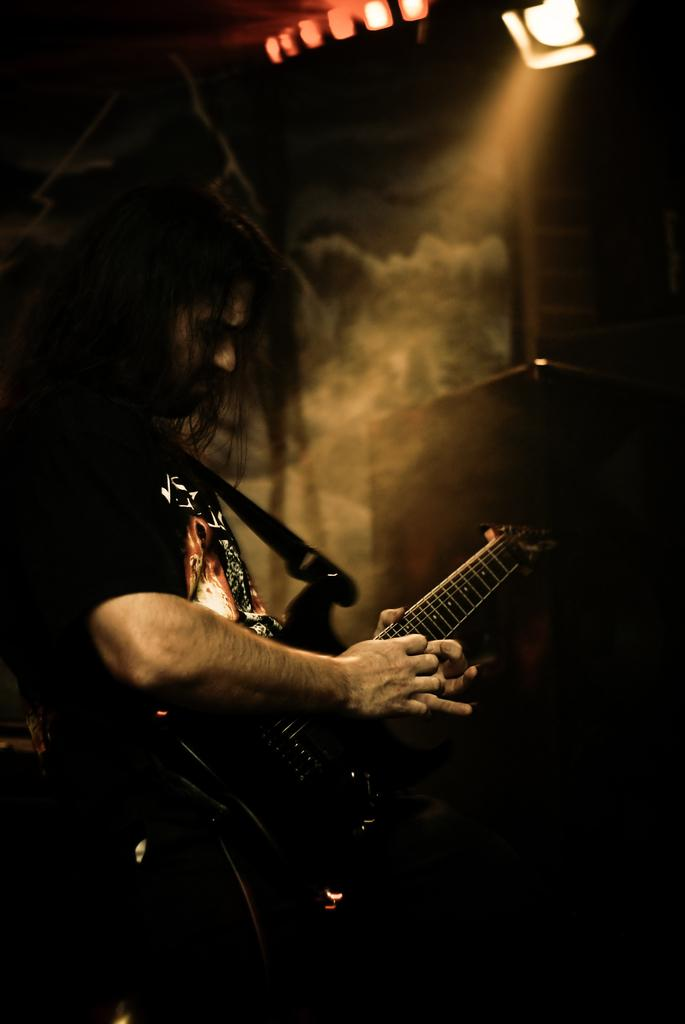Who is the main subject in the image? There is a person in the image. What is the person wearing? The person is wearing a black color T-shirt. What activity is the person engaged in? The person is playing a guitar. What type of fuel is the person using to play the guitar in the image? The person is not using any fuel to play the guitar in the image; they are using their hands and fingers to strum the strings. 